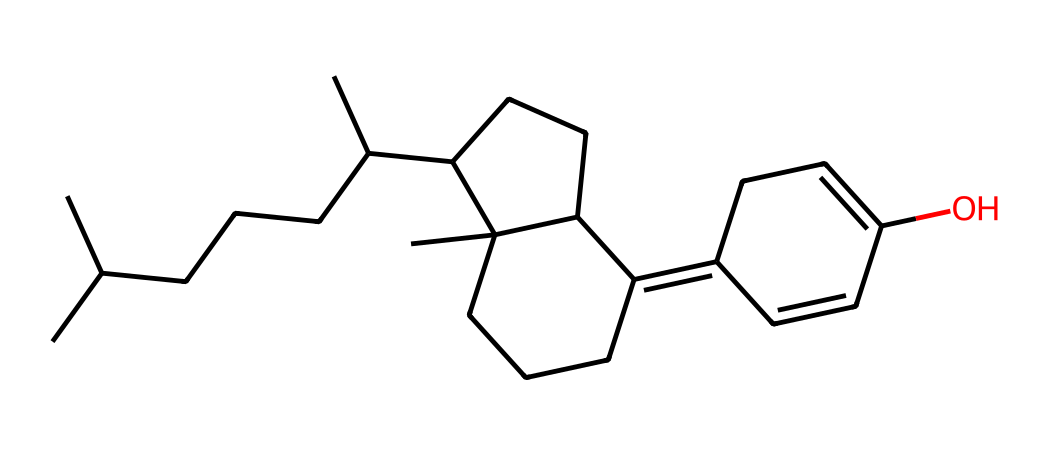What is the main functional group present in this chemical? The chemical contains a hydroxyl (-OH) group, which is characteristic of alcohols. This functional group is visible in the structure as it is connected to a carbon atom, indicating its presence in the compound.
Answer: hydroxyl How many carbons are in the structure? Upon analyzing the SMILES representation, you can count a total of 27 carbon atoms present in the chemical structure. Each 'C' in the SMILES represents a carbon atom, and additional branching leads to more carbons connected, resulting in the total count.
Answer: twenty-seven What is the primary role of vitamin D in the body? Vitamin D primarily supports calcium absorption, which is essential for maintaining bone health. This is related to the functions of the compound illustrated in the structure, as vitamin D influences the regulation of calcium and phosphate in the body.
Answer: calcium absorption What type of vitamin does this structure represent? The structure corresponds to a fat-soluble vitamin, as indicated by the presence of long carbon chains and the ring structure, which are typical characteristics of vitamins like D that are soluble in fat rather than water.
Answer: fat-soluble Can this chemical be synthesized in the body? Yes, vitamin D can be synthesized in the skin through exposure to sunlight, specifically UVB rays, which convert a cholesterol derivative into vitamin D. This elucidates the relationship between sunlight and the synthesis of its active forms in the body.
Answer: yes 